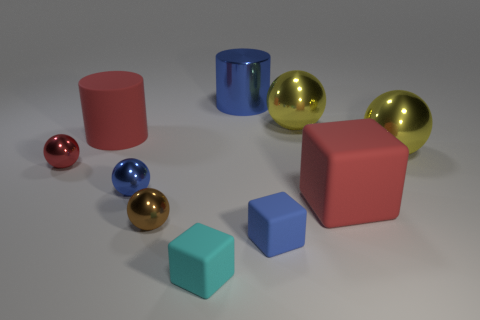Subtract 1 balls. How many balls are left? 4 Subtract all red balls. How many balls are left? 4 Subtract all brown spheres. How many spheres are left? 4 Subtract all gray spheres. Subtract all gray cubes. How many spheres are left? 5 Subtract all cylinders. How many objects are left? 8 Subtract 0 green cylinders. How many objects are left? 10 Subtract all large matte objects. Subtract all small blue cubes. How many objects are left? 7 Add 5 red things. How many red things are left? 8 Add 2 yellow metallic spheres. How many yellow metallic spheres exist? 4 